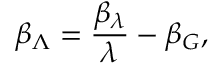Convert formula to latex. <formula><loc_0><loc_0><loc_500><loc_500>\beta _ { \Lambda } = \frac { \beta _ { \lambda } } { \lambda } - \beta _ { G } ,</formula> 